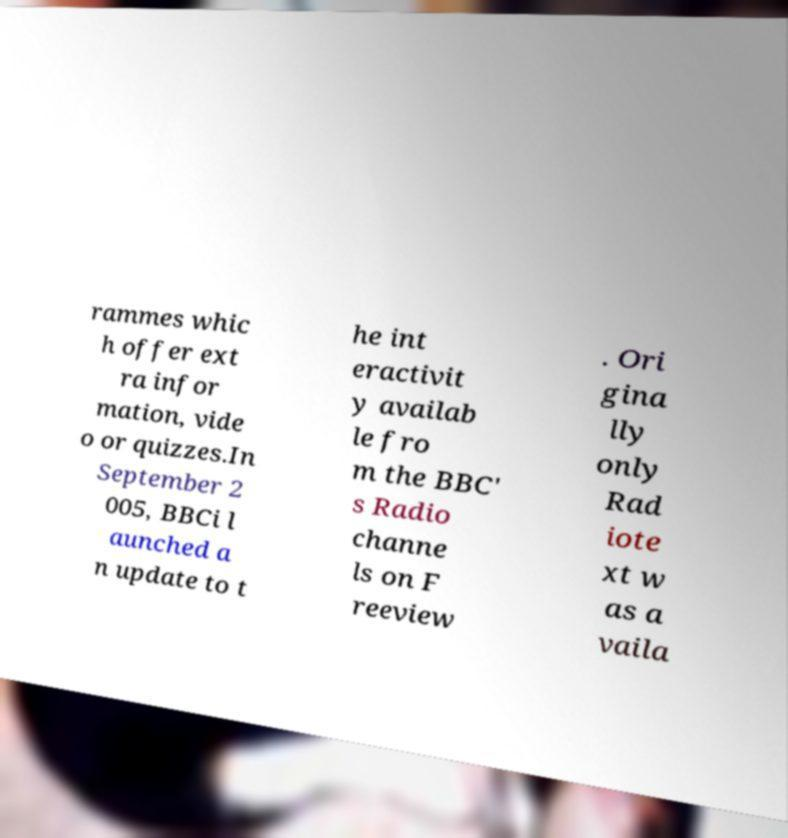Can you accurately transcribe the text from the provided image for me? rammes whic h offer ext ra infor mation, vide o or quizzes.In September 2 005, BBCi l aunched a n update to t he int eractivit y availab le fro m the BBC' s Radio channe ls on F reeview . Ori gina lly only Rad iote xt w as a vaila 